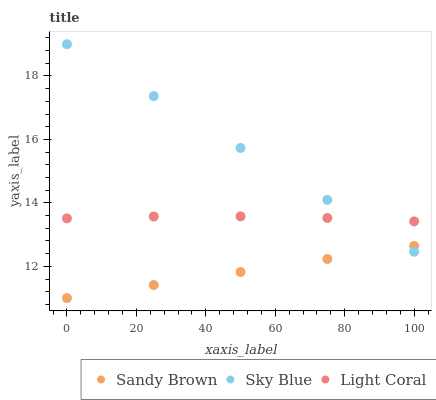Does Sandy Brown have the minimum area under the curve?
Answer yes or no. Yes. Does Sky Blue have the maximum area under the curve?
Answer yes or no. Yes. Does Sky Blue have the minimum area under the curve?
Answer yes or no. No. Does Sandy Brown have the maximum area under the curve?
Answer yes or no. No. Is Sandy Brown the smoothest?
Answer yes or no. Yes. Is Light Coral the roughest?
Answer yes or no. Yes. Is Sky Blue the smoothest?
Answer yes or no. No. Is Sky Blue the roughest?
Answer yes or no. No. Does Sandy Brown have the lowest value?
Answer yes or no. Yes. Does Sky Blue have the lowest value?
Answer yes or no. No. Does Sky Blue have the highest value?
Answer yes or no. Yes. Does Sandy Brown have the highest value?
Answer yes or no. No. Is Sandy Brown less than Light Coral?
Answer yes or no. Yes. Is Light Coral greater than Sandy Brown?
Answer yes or no. Yes. Does Sky Blue intersect Sandy Brown?
Answer yes or no. Yes. Is Sky Blue less than Sandy Brown?
Answer yes or no. No. Is Sky Blue greater than Sandy Brown?
Answer yes or no. No. Does Sandy Brown intersect Light Coral?
Answer yes or no. No. 